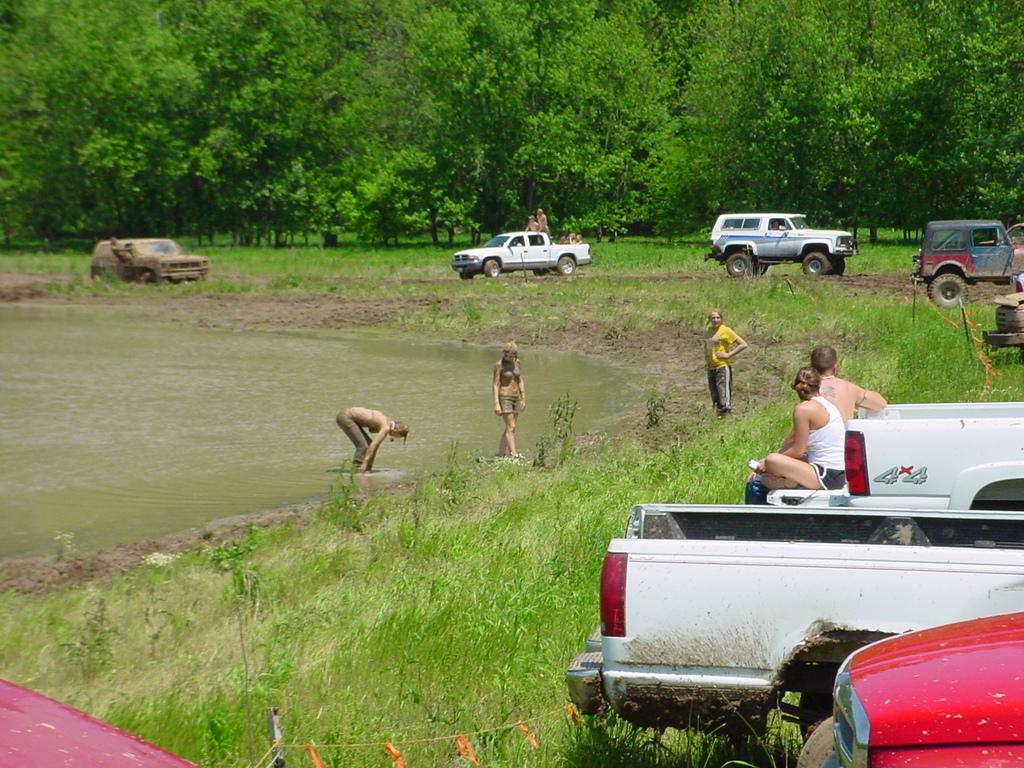What type of vegetation covers the land in the image? The land is covered with grass. What else can be seen in the image besides the grass? There are vehicles and people visible in the image. What can be seen in the background of the image? There are trees in the background of the image. Can you see any fairies flying around the trees in the image? There are no fairies present in the image; it only features grass-covered land, vehicles, people, and trees in the background. 